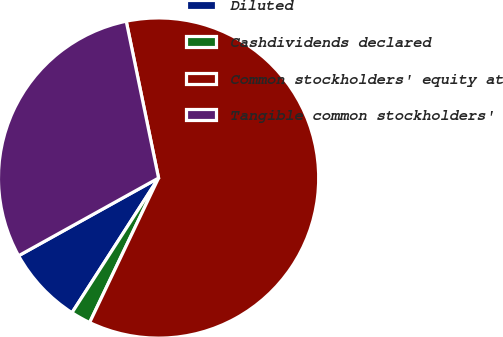<chart> <loc_0><loc_0><loc_500><loc_500><pie_chart><fcel>Diluted<fcel>Cashdividends declared<fcel>Common stockholders' equity at<fcel>Tangible common stockholders'<nl><fcel>7.84%<fcel>2.01%<fcel>60.32%<fcel>29.83%<nl></chart> 